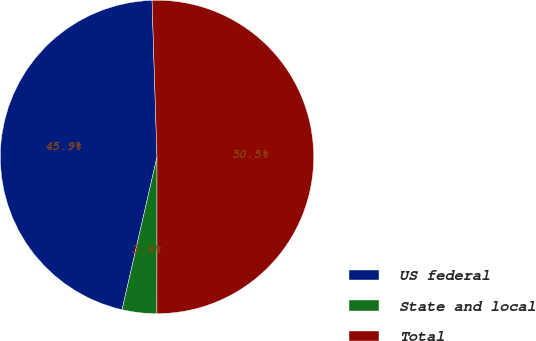Convert chart. <chart><loc_0><loc_0><loc_500><loc_500><pie_chart><fcel>US federal<fcel>State and local<fcel>Total<nl><fcel>45.92%<fcel>3.57%<fcel>50.51%<nl></chart> 